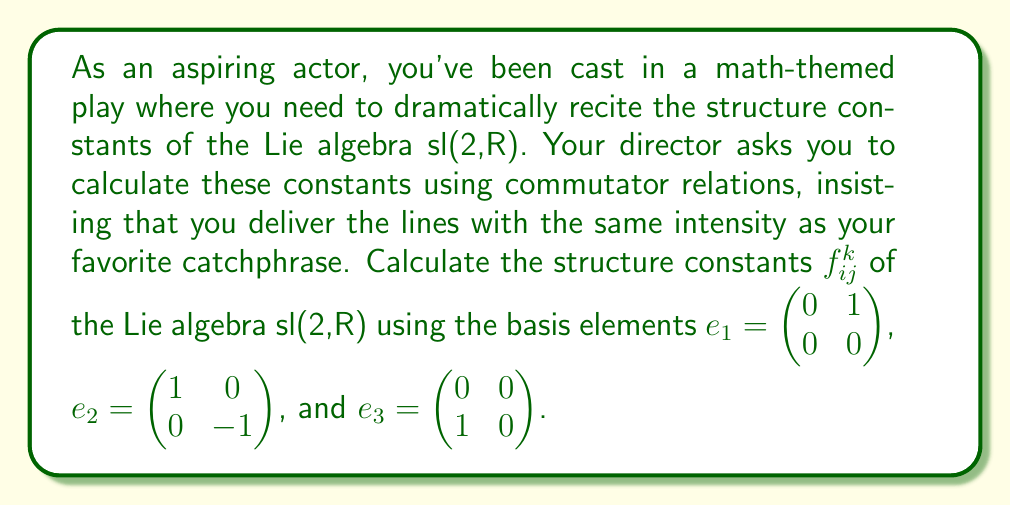Show me your answer to this math problem. To calculate the structure constants of sl(2,R), we need to compute the commutators of the basis elements and express them in terms of the basis. The commutator is defined as $[X,Y] = XY - YX$ for matrices $X$ and $Y$.

1) First, let's calculate $[e_1, e_2]$:
   $$[e_1, e_2] = e_1e_2 - e_2e_1 = \begin{pmatrix} 0 & 1 \\ 0 & 0 \end{pmatrix}\begin{pmatrix} 1 & 0 \\ 0 & -1 \end{pmatrix} - \begin{pmatrix} 1 & 0 \\ 0 & -1 \end{pmatrix}\begin{pmatrix} 0 & 1 \\ 0 & 0 \end{pmatrix} = \begin{pmatrix} 0 & -1 \\ 0 & 0 \end{pmatrix} - \begin{pmatrix} 0 & 1 \\ 0 & 0 \end{pmatrix} = \begin{pmatrix} 0 & -2 \\ 0 & 0 \end{pmatrix} = 2e_1$$

2) Next, $[e_1, e_3]$:
   $$[e_1, e_3] = e_1e_3 - e_3e_1 = \begin{pmatrix} 0 & 1 \\ 0 & 0 \end{pmatrix}\begin{pmatrix} 0 & 0 \\ 1 & 0 \end{pmatrix} - \begin{pmatrix} 0 & 0 \\ 1 & 0 \end{pmatrix}\begin{pmatrix} 0 & 1 \\ 0 & 0 \end{pmatrix} = \begin{pmatrix} 1 & 0 \\ 0 & 0 \end{pmatrix} - \begin{pmatrix} 0 & 0 \\ 0 & -1 \end{pmatrix} = \begin{pmatrix} 1 & 0 \\ 0 & 1 \end{pmatrix} = -e_2$$

3) Finally, $[e_2, e_3]$:
   $$[e_2, e_3] = e_2e_3 - e_3e_2 = \begin{pmatrix} 1 & 0 \\ 0 & -1 \end{pmatrix}\begin{pmatrix} 0 & 0 \\ 1 & 0 \end{pmatrix} - \begin{pmatrix} 0 & 0 \\ 1 & 0 \end{pmatrix}\begin{pmatrix} 1 & 0 \\ 0 & -1 \end{pmatrix} = \begin{pmatrix} 0 & 0 \\ -1 & 0 \end{pmatrix} - \begin{pmatrix} 0 & 0 \\ 1 & 0 \end{pmatrix} = \begin{pmatrix} 0 & 0 \\ -2 & 0 \end{pmatrix} = 2e_3$$

The structure constants $f_{ij}^k$ are defined by the equation $[e_i, e_j] = \sum_k f_{ij}^k e_k$. From our calculations, we can read off:

$f_{12}^1 = 2$, $f_{13}^2 = -1$, $f_{23}^3 = 2$

All other structure constants are zero.
Answer: The non-zero structure constants of sl(2,R) are:
$$f_{12}^1 = 2, \quad f_{13}^2 = -1, \quad f_{23}^3 = 2$$
All other $f_{ij}^k = 0$. 